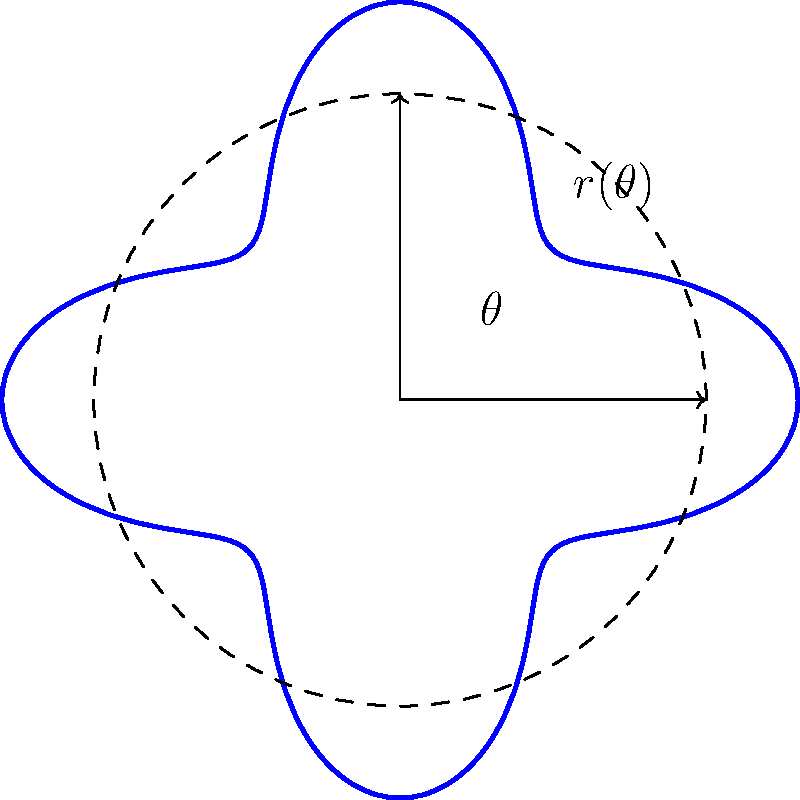In competitive swimming, maintaining a streamlined body position is crucial for reducing drag and maximizing speed. The polar curve $r(\theta) = 1 + 0.3\cos(4\theta)$ represents the cross-sectional shape of a swimmer's body in the streamlined position. What is the maximum deviation of the swimmer's body from a perfect circle, and at how many points does this maximum deviation occur? To solve this problem, we'll follow these steps:

1) The equation $r(\theta) = 1 + 0.3\cos(4\theta)$ represents a polar curve where:
   - The base radius is 1
   - The amplitude of the variation is 0.3
   - The frequency of the variation is 4

2) The maximum deviation occurs when $\cos(4\theta)$ is at its extreme values:
   - Maximum: when $\cos(4\theta) = 1$, $r_{max} = 1 + 0.3 = 1.3$
   - Minimum: when $\cos(4\theta) = -1$, $r_{min} = 1 - 0.3 = 0.7$

3) The maximum deviation from the circle (radius 1) is:
   $\text{Max deviation} = \max(|1.3 - 1|, |0.7 - 1|) = 0.3$

4) To find how many times this maximum deviation occurs, we need to solve:
   $\cos(4\theta) = \pm 1$

   This occurs when $4\theta = 0, \pi, 2\pi, 3\pi, \ldots$ (for positive deviations)
   and when $4\theta = \pi, 3\pi, 5\pi, \ldots$ (for negative deviations)

5) In one full rotation $(0 \leq \theta < 2\pi)$, this happens 8 times:
   4 times for positive deviations and 4 times for negative deviations.

Therefore, the maximum deviation is 0.3 units, and it occurs at 8 points around the curve.
Answer: 0.3 units; 8 points 